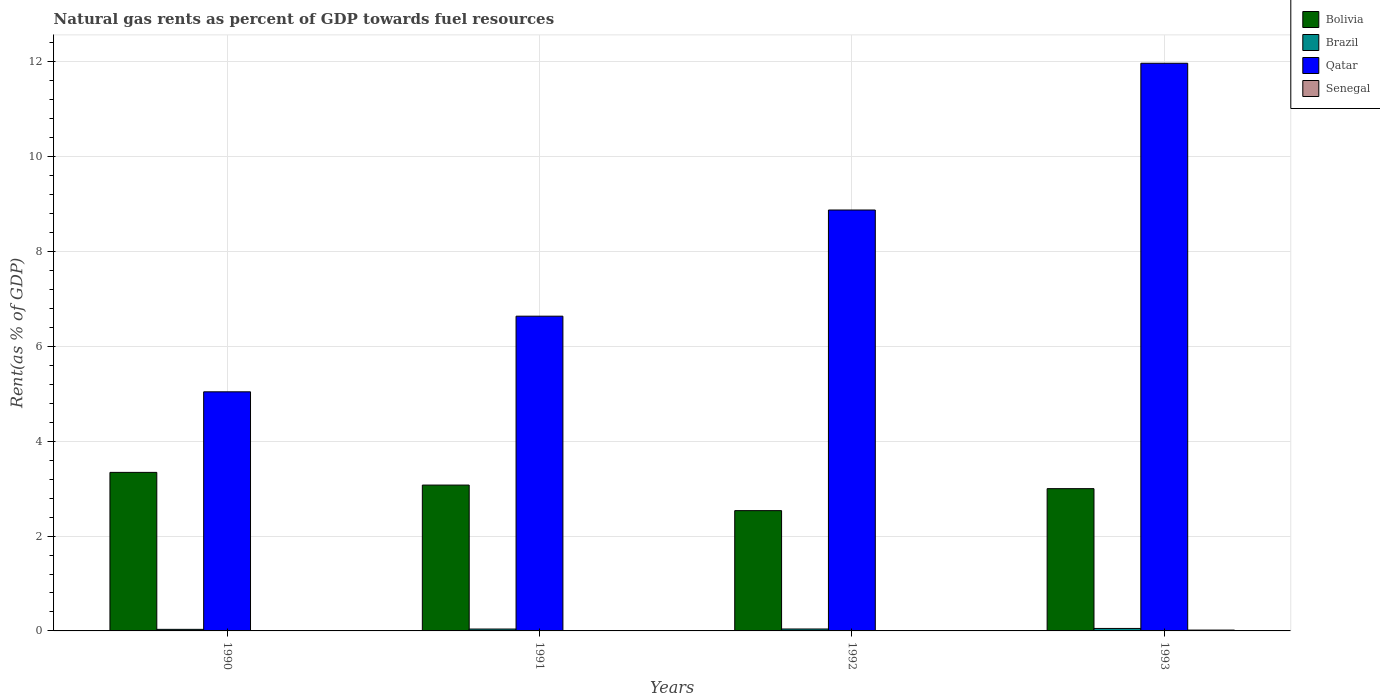Are the number of bars per tick equal to the number of legend labels?
Offer a terse response. Yes. How many bars are there on the 2nd tick from the left?
Offer a very short reply. 4. How many bars are there on the 4th tick from the right?
Provide a short and direct response. 4. What is the matural gas rent in Senegal in 1993?
Offer a very short reply. 0.02. Across all years, what is the maximum matural gas rent in Senegal?
Make the answer very short. 0.02. Across all years, what is the minimum matural gas rent in Qatar?
Provide a succinct answer. 5.04. What is the total matural gas rent in Qatar in the graph?
Your response must be concise. 32.53. What is the difference between the matural gas rent in Senegal in 1990 and that in 1993?
Ensure brevity in your answer.  -0.01. What is the difference between the matural gas rent in Senegal in 1992 and the matural gas rent in Bolivia in 1991?
Keep it short and to the point. -3.07. What is the average matural gas rent in Bolivia per year?
Keep it short and to the point. 2.99. In the year 1991, what is the difference between the matural gas rent in Qatar and matural gas rent in Bolivia?
Keep it short and to the point. 3.56. In how many years, is the matural gas rent in Qatar greater than 4 %?
Ensure brevity in your answer.  4. What is the ratio of the matural gas rent in Bolivia in 1990 to that in 1992?
Give a very brief answer. 1.32. Is the matural gas rent in Qatar in 1990 less than that in 1993?
Your answer should be compact. Yes. What is the difference between the highest and the second highest matural gas rent in Qatar?
Keep it short and to the point. 3.09. What is the difference between the highest and the lowest matural gas rent in Brazil?
Provide a short and direct response. 0.02. Is the sum of the matural gas rent in Qatar in 1991 and 1992 greater than the maximum matural gas rent in Brazil across all years?
Offer a very short reply. Yes. What does the 3rd bar from the left in 1990 represents?
Provide a succinct answer. Qatar. What does the 1st bar from the right in 1991 represents?
Provide a succinct answer. Senegal. How many bars are there?
Make the answer very short. 16. Are all the bars in the graph horizontal?
Provide a succinct answer. No. How many legend labels are there?
Your response must be concise. 4. How are the legend labels stacked?
Ensure brevity in your answer.  Vertical. What is the title of the graph?
Keep it short and to the point. Natural gas rents as percent of GDP towards fuel resources. What is the label or title of the X-axis?
Provide a short and direct response. Years. What is the label or title of the Y-axis?
Your answer should be very brief. Rent(as % of GDP). What is the Rent(as % of GDP) of Bolivia in 1990?
Your response must be concise. 3.34. What is the Rent(as % of GDP) of Brazil in 1990?
Ensure brevity in your answer.  0.03. What is the Rent(as % of GDP) of Qatar in 1990?
Your answer should be compact. 5.04. What is the Rent(as % of GDP) of Senegal in 1990?
Offer a terse response. 0.01. What is the Rent(as % of GDP) in Bolivia in 1991?
Provide a succinct answer. 3.08. What is the Rent(as % of GDP) in Brazil in 1991?
Give a very brief answer. 0.04. What is the Rent(as % of GDP) in Qatar in 1991?
Offer a terse response. 6.64. What is the Rent(as % of GDP) in Senegal in 1991?
Your answer should be compact. 0.01. What is the Rent(as % of GDP) in Bolivia in 1992?
Provide a succinct answer. 2.54. What is the Rent(as % of GDP) in Brazil in 1992?
Offer a very short reply. 0.04. What is the Rent(as % of GDP) in Qatar in 1992?
Provide a succinct answer. 8.88. What is the Rent(as % of GDP) of Senegal in 1992?
Keep it short and to the point. 0. What is the Rent(as % of GDP) in Bolivia in 1993?
Your response must be concise. 3. What is the Rent(as % of GDP) of Brazil in 1993?
Ensure brevity in your answer.  0.05. What is the Rent(as % of GDP) in Qatar in 1993?
Your answer should be very brief. 11.97. What is the Rent(as % of GDP) in Senegal in 1993?
Provide a succinct answer. 0.02. Across all years, what is the maximum Rent(as % of GDP) in Bolivia?
Your answer should be very brief. 3.34. Across all years, what is the maximum Rent(as % of GDP) in Brazil?
Ensure brevity in your answer.  0.05. Across all years, what is the maximum Rent(as % of GDP) of Qatar?
Your response must be concise. 11.97. Across all years, what is the maximum Rent(as % of GDP) in Senegal?
Your response must be concise. 0.02. Across all years, what is the minimum Rent(as % of GDP) of Bolivia?
Offer a terse response. 2.54. Across all years, what is the minimum Rent(as % of GDP) in Brazil?
Your answer should be very brief. 0.03. Across all years, what is the minimum Rent(as % of GDP) of Qatar?
Make the answer very short. 5.04. Across all years, what is the minimum Rent(as % of GDP) in Senegal?
Your answer should be very brief. 0. What is the total Rent(as % of GDP) in Bolivia in the graph?
Offer a very short reply. 11.96. What is the total Rent(as % of GDP) in Brazil in the graph?
Ensure brevity in your answer.  0.17. What is the total Rent(as % of GDP) of Qatar in the graph?
Provide a succinct answer. 32.53. What is the total Rent(as % of GDP) in Senegal in the graph?
Give a very brief answer. 0.03. What is the difference between the Rent(as % of GDP) in Bolivia in 1990 and that in 1991?
Offer a very short reply. 0.27. What is the difference between the Rent(as % of GDP) of Brazil in 1990 and that in 1991?
Give a very brief answer. -0.01. What is the difference between the Rent(as % of GDP) of Qatar in 1990 and that in 1991?
Provide a short and direct response. -1.6. What is the difference between the Rent(as % of GDP) of Senegal in 1990 and that in 1991?
Your answer should be very brief. 0. What is the difference between the Rent(as % of GDP) of Bolivia in 1990 and that in 1992?
Provide a succinct answer. 0.81. What is the difference between the Rent(as % of GDP) in Brazil in 1990 and that in 1992?
Make the answer very short. -0.01. What is the difference between the Rent(as % of GDP) of Qatar in 1990 and that in 1992?
Offer a very short reply. -3.83. What is the difference between the Rent(as % of GDP) of Senegal in 1990 and that in 1992?
Make the answer very short. 0. What is the difference between the Rent(as % of GDP) in Bolivia in 1990 and that in 1993?
Your answer should be very brief. 0.34. What is the difference between the Rent(as % of GDP) in Brazil in 1990 and that in 1993?
Your answer should be very brief. -0.02. What is the difference between the Rent(as % of GDP) in Qatar in 1990 and that in 1993?
Keep it short and to the point. -6.93. What is the difference between the Rent(as % of GDP) in Senegal in 1990 and that in 1993?
Your answer should be very brief. -0.01. What is the difference between the Rent(as % of GDP) in Bolivia in 1991 and that in 1992?
Your response must be concise. 0.54. What is the difference between the Rent(as % of GDP) in Brazil in 1991 and that in 1992?
Your response must be concise. -0. What is the difference between the Rent(as % of GDP) of Qatar in 1991 and that in 1992?
Offer a terse response. -2.24. What is the difference between the Rent(as % of GDP) in Senegal in 1991 and that in 1992?
Your answer should be very brief. 0. What is the difference between the Rent(as % of GDP) of Bolivia in 1991 and that in 1993?
Your answer should be compact. 0.08. What is the difference between the Rent(as % of GDP) of Brazil in 1991 and that in 1993?
Your answer should be very brief. -0.01. What is the difference between the Rent(as % of GDP) in Qatar in 1991 and that in 1993?
Provide a short and direct response. -5.33. What is the difference between the Rent(as % of GDP) in Senegal in 1991 and that in 1993?
Offer a very short reply. -0.01. What is the difference between the Rent(as % of GDP) of Bolivia in 1992 and that in 1993?
Offer a terse response. -0.46. What is the difference between the Rent(as % of GDP) in Brazil in 1992 and that in 1993?
Your answer should be very brief. -0.01. What is the difference between the Rent(as % of GDP) of Qatar in 1992 and that in 1993?
Give a very brief answer. -3.09. What is the difference between the Rent(as % of GDP) of Senegal in 1992 and that in 1993?
Keep it short and to the point. -0.01. What is the difference between the Rent(as % of GDP) in Bolivia in 1990 and the Rent(as % of GDP) in Brazil in 1991?
Keep it short and to the point. 3.3. What is the difference between the Rent(as % of GDP) of Bolivia in 1990 and the Rent(as % of GDP) of Qatar in 1991?
Offer a very short reply. -3.29. What is the difference between the Rent(as % of GDP) in Bolivia in 1990 and the Rent(as % of GDP) in Senegal in 1991?
Offer a terse response. 3.34. What is the difference between the Rent(as % of GDP) in Brazil in 1990 and the Rent(as % of GDP) in Qatar in 1991?
Offer a very short reply. -6.6. What is the difference between the Rent(as % of GDP) in Brazil in 1990 and the Rent(as % of GDP) in Senegal in 1991?
Give a very brief answer. 0.03. What is the difference between the Rent(as % of GDP) in Qatar in 1990 and the Rent(as % of GDP) in Senegal in 1991?
Ensure brevity in your answer.  5.04. What is the difference between the Rent(as % of GDP) of Bolivia in 1990 and the Rent(as % of GDP) of Brazil in 1992?
Ensure brevity in your answer.  3.3. What is the difference between the Rent(as % of GDP) in Bolivia in 1990 and the Rent(as % of GDP) in Qatar in 1992?
Provide a short and direct response. -5.53. What is the difference between the Rent(as % of GDP) of Bolivia in 1990 and the Rent(as % of GDP) of Senegal in 1992?
Your answer should be compact. 3.34. What is the difference between the Rent(as % of GDP) of Brazil in 1990 and the Rent(as % of GDP) of Qatar in 1992?
Provide a succinct answer. -8.84. What is the difference between the Rent(as % of GDP) in Brazil in 1990 and the Rent(as % of GDP) in Senegal in 1992?
Offer a very short reply. 0.03. What is the difference between the Rent(as % of GDP) of Qatar in 1990 and the Rent(as % of GDP) of Senegal in 1992?
Make the answer very short. 5.04. What is the difference between the Rent(as % of GDP) of Bolivia in 1990 and the Rent(as % of GDP) of Brazil in 1993?
Your answer should be very brief. 3.29. What is the difference between the Rent(as % of GDP) in Bolivia in 1990 and the Rent(as % of GDP) in Qatar in 1993?
Give a very brief answer. -8.63. What is the difference between the Rent(as % of GDP) of Bolivia in 1990 and the Rent(as % of GDP) of Senegal in 1993?
Provide a succinct answer. 3.33. What is the difference between the Rent(as % of GDP) of Brazil in 1990 and the Rent(as % of GDP) of Qatar in 1993?
Provide a short and direct response. -11.94. What is the difference between the Rent(as % of GDP) in Brazil in 1990 and the Rent(as % of GDP) in Senegal in 1993?
Provide a short and direct response. 0.02. What is the difference between the Rent(as % of GDP) in Qatar in 1990 and the Rent(as % of GDP) in Senegal in 1993?
Your answer should be compact. 5.02. What is the difference between the Rent(as % of GDP) of Bolivia in 1991 and the Rent(as % of GDP) of Brazil in 1992?
Give a very brief answer. 3.04. What is the difference between the Rent(as % of GDP) of Bolivia in 1991 and the Rent(as % of GDP) of Qatar in 1992?
Provide a succinct answer. -5.8. What is the difference between the Rent(as % of GDP) of Bolivia in 1991 and the Rent(as % of GDP) of Senegal in 1992?
Your answer should be compact. 3.07. What is the difference between the Rent(as % of GDP) of Brazil in 1991 and the Rent(as % of GDP) of Qatar in 1992?
Your answer should be compact. -8.84. What is the difference between the Rent(as % of GDP) of Brazil in 1991 and the Rent(as % of GDP) of Senegal in 1992?
Provide a short and direct response. 0.04. What is the difference between the Rent(as % of GDP) of Qatar in 1991 and the Rent(as % of GDP) of Senegal in 1992?
Your answer should be compact. 6.63. What is the difference between the Rent(as % of GDP) in Bolivia in 1991 and the Rent(as % of GDP) in Brazil in 1993?
Make the answer very short. 3.02. What is the difference between the Rent(as % of GDP) of Bolivia in 1991 and the Rent(as % of GDP) of Qatar in 1993?
Provide a short and direct response. -8.9. What is the difference between the Rent(as % of GDP) of Bolivia in 1991 and the Rent(as % of GDP) of Senegal in 1993?
Give a very brief answer. 3.06. What is the difference between the Rent(as % of GDP) of Brazil in 1991 and the Rent(as % of GDP) of Qatar in 1993?
Your response must be concise. -11.93. What is the difference between the Rent(as % of GDP) in Brazil in 1991 and the Rent(as % of GDP) in Senegal in 1993?
Make the answer very short. 0.02. What is the difference between the Rent(as % of GDP) in Qatar in 1991 and the Rent(as % of GDP) in Senegal in 1993?
Ensure brevity in your answer.  6.62. What is the difference between the Rent(as % of GDP) of Bolivia in 1992 and the Rent(as % of GDP) of Brazil in 1993?
Offer a terse response. 2.48. What is the difference between the Rent(as % of GDP) in Bolivia in 1992 and the Rent(as % of GDP) in Qatar in 1993?
Keep it short and to the point. -9.43. What is the difference between the Rent(as % of GDP) in Bolivia in 1992 and the Rent(as % of GDP) in Senegal in 1993?
Offer a very short reply. 2.52. What is the difference between the Rent(as % of GDP) of Brazil in 1992 and the Rent(as % of GDP) of Qatar in 1993?
Your answer should be very brief. -11.93. What is the difference between the Rent(as % of GDP) of Brazil in 1992 and the Rent(as % of GDP) of Senegal in 1993?
Your answer should be compact. 0.02. What is the difference between the Rent(as % of GDP) in Qatar in 1992 and the Rent(as % of GDP) in Senegal in 1993?
Offer a very short reply. 8.86. What is the average Rent(as % of GDP) of Bolivia per year?
Your answer should be very brief. 2.99. What is the average Rent(as % of GDP) of Brazil per year?
Your answer should be compact. 0.04. What is the average Rent(as % of GDP) in Qatar per year?
Make the answer very short. 8.13. What is the average Rent(as % of GDP) of Senegal per year?
Make the answer very short. 0.01. In the year 1990, what is the difference between the Rent(as % of GDP) of Bolivia and Rent(as % of GDP) of Brazil?
Your answer should be compact. 3.31. In the year 1990, what is the difference between the Rent(as % of GDP) in Bolivia and Rent(as % of GDP) in Qatar?
Provide a succinct answer. -1.7. In the year 1990, what is the difference between the Rent(as % of GDP) in Bolivia and Rent(as % of GDP) in Senegal?
Give a very brief answer. 3.34. In the year 1990, what is the difference between the Rent(as % of GDP) of Brazil and Rent(as % of GDP) of Qatar?
Your answer should be compact. -5.01. In the year 1990, what is the difference between the Rent(as % of GDP) in Brazil and Rent(as % of GDP) in Senegal?
Your answer should be compact. 0.03. In the year 1990, what is the difference between the Rent(as % of GDP) of Qatar and Rent(as % of GDP) of Senegal?
Your answer should be compact. 5.04. In the year 1991, what is the difference between the Rent(as % of GDP) of Bolivia and Rent(as % of GDP) of Brazil?
Your answer should be very brief. 3.04. In the year 1991, what is the difference between the Rent(as % of GDP) of Bolivia and Rent(as % of GDP) of Qatar?
Your answer should be very brief. -3.56. In the year 1991, what is the difference between the Rent(as % of GDP) of Bolivia and Rent(as % of GDP) of Senegal?
Your response must be concise. 3.07. In the year 1991, what is the difference between the Rent(as % of GDP) of Brazil and Rent(as % of GDP) of Qatar?
Your answer should be very brief. -6.6. In the year 1991, what is the difference between the Rent(as % of GDP) in Brazil and Rent(as % of GDP) in Senegal?
Provide a short and direct response. 0.03. In the year 1991, what is the difference between the Rent(as % of GDP) in Qatar and Rent(as % of GDP) in Senegal?
Your answer should be very brief. 6.63. In the year 1992, what is the difference between the Rent(as % of GDP) of Bolivia and Rent(as % of GDP) of Brazil?
Offer a very short reply. 2.5. In the year 1992, what is the difference between the Rent(as % of GDP) in Bolivia and Rent(as % of GDP) in Qatar?
Your answer should be compact. -6.34. In the year 1992, what is the difference between the Rent(as % of GDP) of Bolivia and Rent(as % of GDP) of Senegal?
Give a very brief answer. 2.53. In the year 1992, what is the difference between the Rent(as % of GDP) of Brazil and Rent(as % of GDP) of Qatar?
Offer a very short reply. -8.84. In the year 1992, what is the difference between the Rent(as % of GDP) in Brazil and Rent(as % of GDP) in Senegal?
Provide a succinct answer. 0.04. In the year 1992, what is the difference between the Rent(as % of GDP) of Qatar and Rent(as % of GDP) of Senegal?
Offer a very short reply. 8.87. In the year 1993, what is the difference between the Rent(as % of GDP) in Bolivia and Rent(as % of GDP) in Brazil?
Offer a very short reply. 2.95. In the year 1993, what is the difference between the Rent(as % of GDP) of Bolivia and Rent(as % of GDP) of Qatar?
Offer a terse response. -8.97. In the year 1993, what is the difference between the Rent(as % of GDP) of Bolivia and Rent(as % of GDP) of Senegal?
Make the answer very short. 2.98. In the year 1993, what is the difference between the Rent(as % of GDP) of Brazil and Rent(as % of GDP) of Qatar?
Offer a very short reply. -11.92. In the year 1993, what is the difference between the Rent(as % of GDP) in Brazil and Rent(as % of GDP) in Senegal?
Your response must be concise. 0.03. In the year 1993, what is the difference between the Rent(as % of GDP) in Qatar and Rent(as % of GDP) in Senegal?
Offer a terse response. 11.95. What is the ratio of the Rent(as % of GDP) of Bolivia in 1990 to that in 1991?
Your response must be concise. 1.09. What is the ratio of the Rent(as % of GDP) of Brazil in 1990 to that in 1991?
Ensure brevity in your answer.  0.84. What is the ratio of the Rent(as % of GDP) in Qatar in 1990 to that in 1991?
Offer a very short reply. 0.76. What is the ratio of the Rent(as % of GDP) of Senegal in 1990 to that in 1991?
Ensure brevity in your answer.  1.25. What is the ratio of the Rent(as % of GDP) of Bolivia in 1990 to that in 1992?
Ensure brevity in your answer.  1.32. What is the ratio of the Rent(as % of GDP) in Brazil in 1990 to that in 1992?
Provide a short and direct response. 0.81. What is the ratio of the Rent(as % of GDP) in Qatar in 1990 to that in 1992?
Give a very brief answer. 0.57. What is the ratio of the Rent(as % of GDP) in Senegal in 1990 to that in 1992?
Give a very brief answer. 2.4. What is the ratio of the Rent(as % of GDP) in Bolivia in 1990 to that in 1993?
Give a very brief answer. 1.11. What is the ratio of the Rent(as % of GDP) in Brazil in 1990 to that in 1993?
Offer a terse response. 0.63. What is the ratio of the Rent(as % of GDP) in Qatar in 1990 to that in 1993?
Offer a very short reply. 0.42. What is the ratio of the Rent(as % of GDP) in Senegal in 1990 to that in 1993?
Your answer should be very brief. 0.41. What is the ratio of the Rent(as % of GDP) in Bolivia in 1991 to that in 1992?
Your answer should be very brief. 1.21. What is the ratio of the Rent(as % of GDP) in Brazil in 1991 to that in 1992?
Offer a very short reply. 0.97. What is the ratio of the Rent(as % of GDP) of Qatar in 1991 to that in 1992?
Your response must be concise. 0.75. What is the ratio of the Rent(as % of GDP) in Senegal in 1991 to that in 1992?
Your answer should be compact. 1.92. What is the ratio of the Rent(as % of GDP) of Bolivia in 1991 to that in 1993?
Ensure brevity in your answer.  1.03. What is the ratio of the Rent(as % of GDP) in Brazil in 1991 to that in 1993?
Your answer should be very brief. 0.76. What is the ratio of the Rent(as % of GDP) in Qatar in 1991 to that in 1993?
Provide a succinct answer. 0.55. What is the ratio of the Rent(as % of GDP) of Senegal in 1991 to that in 1993?
Keep it short and to the point. 0.32. What is the ratio of the Rent(as % of GDP) of Bolivia in 1992 to that in 1993?
Ensure brevity in your answer.  0.85. What is the ratio of the Rent(as % of GDP) of Brazil in 1992 to that in 1993?
Keep it short and to the point. 0.78. What is the ratio of the Rent(as % of GDP) of Qatar in 1992 to that in 1993?
Make the answer very short. 0.74. What is the ratio of the Rent(as % of GDP) of Senegal in 1992 to that in 1993?
Your response must be concise. 0.17. What is the difference between the highest and the second highest Rent(as % of GDP) of Bolivia?
Your answer should be very brief. 0.27. What is the difference between the highest and the second highest Rent(as % of GDP) of Brazil?
Your answer should be very brief. 0.01. What is the difference between the highest and the second highest Rent(as % of GDP) in Qatar?
Make the answer very short. 3.09. What is the difference between the highest and the second highest Rent(as % of GDP) in Senegal?
Provide a succinct answer. 0.01. What is the difference between the highest and the lowest Rent(as % of GDP) in Bolivia?
Make the answer very short. 0.81. What is the difference between the highest and the lowest Rent(as % of GDP) of Brazil?
Make the answer very short. 0.02. What is the difference between the highest and the lowest Rent(as % of GDP) in Qatar?
Give a very brief answer. 6.93. What is the difference between the highest and the lowest Rent(as % of GDP) of Senegal?
Give a very brief answer. 0.01. 